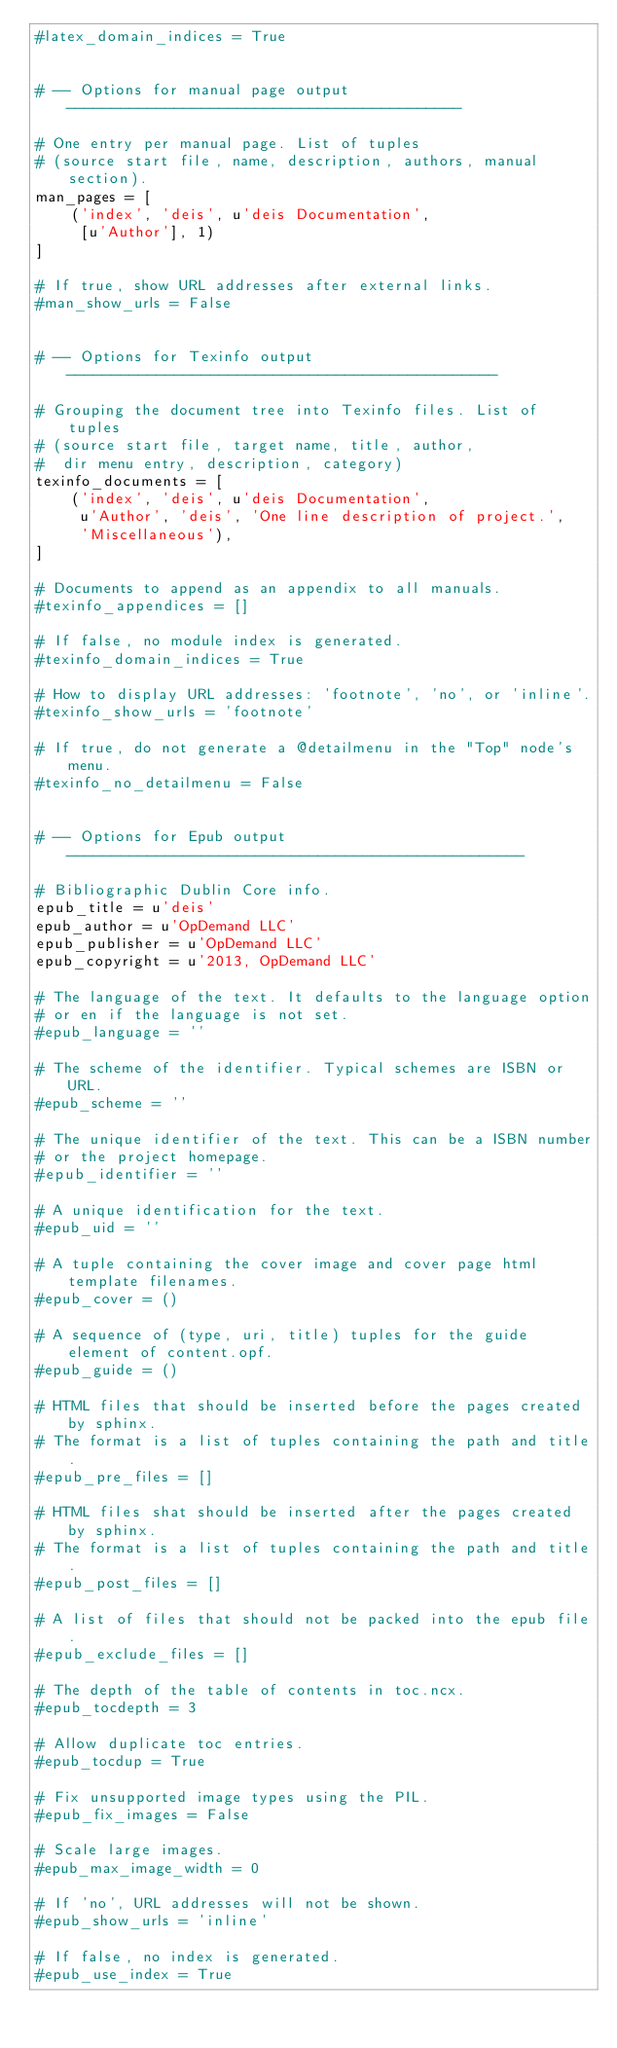Convert code to text. <code><loc_0><loc_0><loc_500><loc_500><_Python_>#latex_domain_indices = True


# -- Options for manual page output --------------------------------------------

# One entry per manual page. List of tuples
# (source start file, name, description, authors, manual section).
man_pages = [
    ('index', 'deis', u'deis Documentation',
     [u'Author'], 1)
]

# If true, show URL addresses after external links.
#man_show_urls = False


# -- Options for Texinfo output ------------------------------------------------

# Grouping the document tree into Texinfo files. List of tuples
# (source start file, target name, title, author,
#  dir menu entry, description, category)
texinfo_documents = [
    ('index', 'deis', u'deis Documentation',
     u'Author', 'deis', 'One line description of project.',
     'Miscellaneous'),
]

# Documents to append as an appendix to all manuals.
#texinfo_appendices = []

# If false, no module index is generated.
#texinfo_domain_indices = True

# How to display URL addresses: 'footnote', 'no', or 'inline'.
#texinfo_show_urls = 'footnote'

# If true, do not generate a @detailmenu in the "Top" node's menu.
#texinfo_no_detailmenu = False


# -- Options for Epub output ---------------------------------------------------

# Bibliographic Dublin Core info.
epub_title = u'deis'
epub_author = u'OpDemand LLC'
epub_publisher = u'OpDemand LLC'
epub_copyright = u'2013, OpDemand LLC'

# The language of the text. It defaults to the language option
# or en if the language is not set.
#epub_language = ''

# The scheme of the identifier. Typical schemes are ISBN or URL.
#epub_scheme = ''

# The unique identifier of the text. This can be a ISBN number
# or the project homepage.
#epub_identifier = ''

# A unique identification for the text.
#epub_uid = ''

# A tuple containing the cover image and cover page html template filenames.
#epub_cover = ()

# A sequence of (type, uri, title) tuples for the guide element of content.opf.
#epub_guide = ()

# HTML files that should be inserted before the pages created by sphinx.
# The format is a list of tuples containing the path and title.
#epub_pre_files = []

# HTML files shat should be inserted after the pages created by sphinx.
# The format is a list of tuples containing the path and title.
#epub_post_files = []

# A list of files that should not be packed into the epub file.
#epub_exclude_files = []

# The depth of the table of contents in toc.ncx.
#epub_tocdepth = 3

# Allow duplicate toc entries.
#epub_tocdup = True

# Fix unsupported image types using the PIL.
#epub_fix_images = False

# Scale large images.
#epub_max_image_width = 0

# If 'no', URL addresses will not be shown.
#epub_show_urls = 'inline'

# If false, no index is generated.
#epub_use_index = True
</code> 